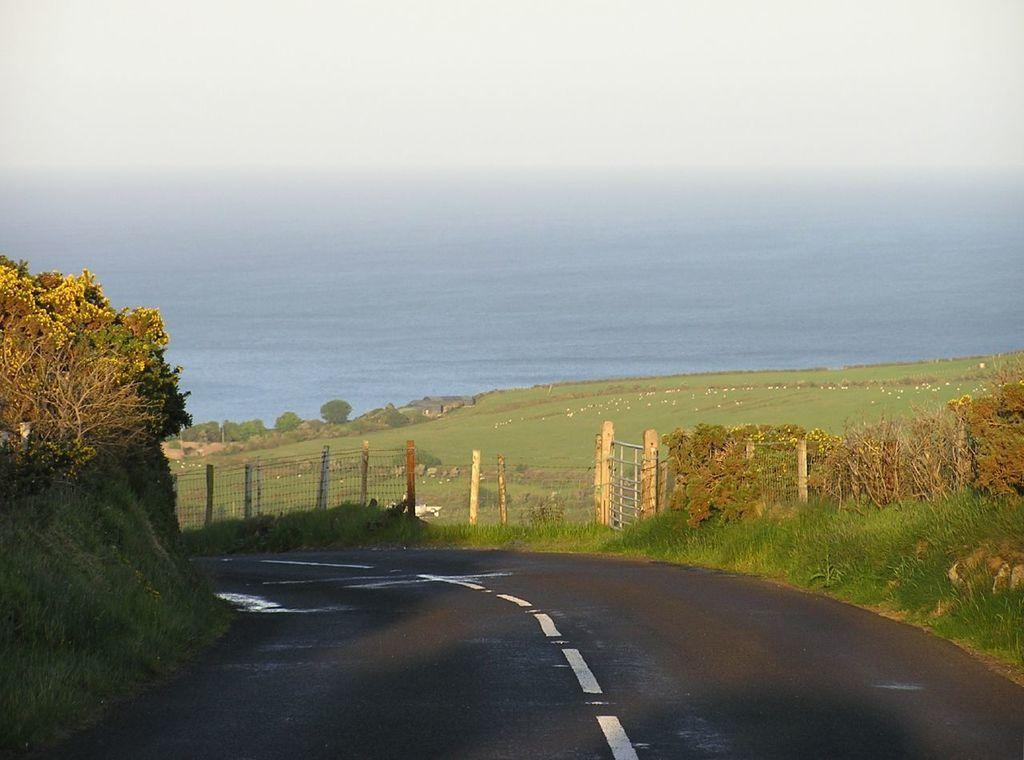What is the main feature of the image? There is a road in the image. What can be seen beside the road? There is a fence beside the road. What type of vegetation is present in the image? There are trees in the image. What is visible in the background of the image? Water and the sky are visible in the background of the image. What type of tax is being discussed by the people in the image? There are no people present in the image, and therefore no discussion about taxes can be observed. What color is the sheet draped over the tree in the image? There is no sheet present in the image; only the road, fence, trees, water, and sky are visible. 